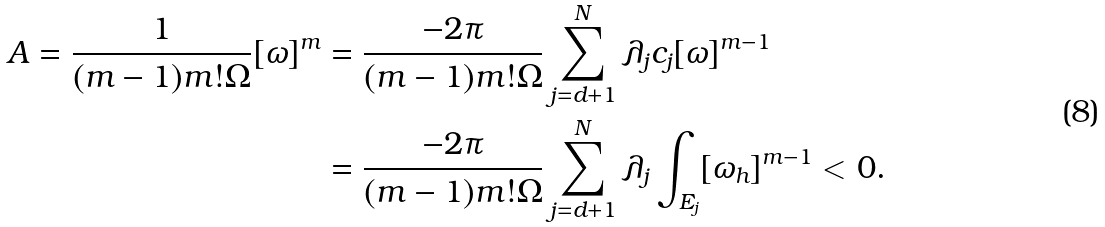<formula> <loc_0><loc_0><loc_500><loc_500>A = \frac { 1 } { ( m - 1 ) m ! \Omega } [ \omega ] ^ { m } & = \frac { - 2 \pi } { ( m - 1 ) m ! \Omega } \sum _ { j = d + 1 } ^ { N } \lambda _ { j } c _ { j } [ \omega ] ^ { m - 1 } \\ & = \frac { - 2 \pi } { ( m - 1 ) m ! \Omega } \sum _ { j = d + 1 } ^ { N } \lambda _ { j } \int _ { E _ { j } } [ \omega _ { h } ] ^ { m - 1 } < 0 .</formula> 